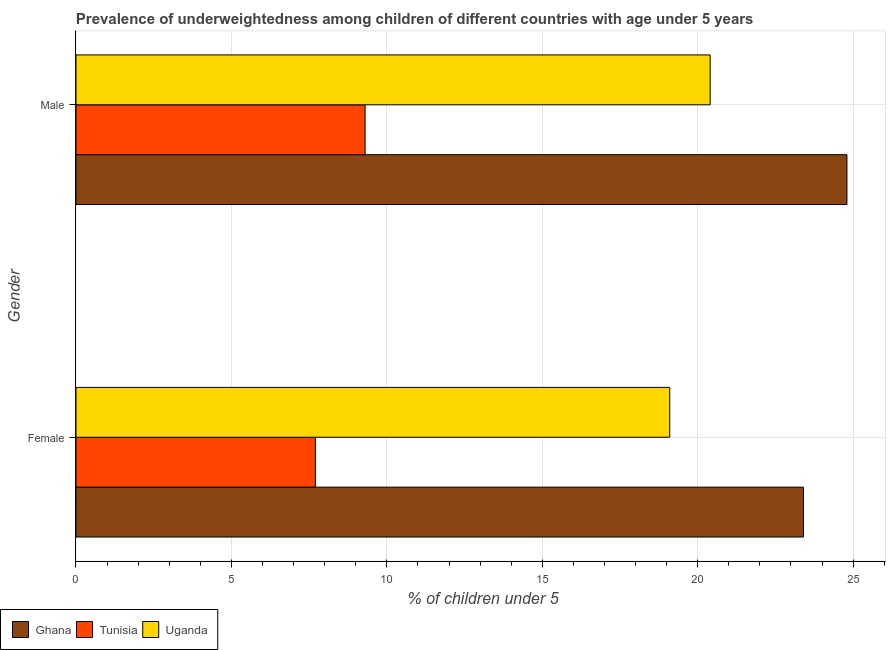How many different coloured bars are there?
Provide a succinct answer. 3. How many groups of bars are there?
Your answer should be very brief. 2. Are the number of bars on each tick of the Y-axis equal?
Provide a succinct answer. Yes. How many bars are there on the 2nd tick from the bottom?
Offer a very short reply. 3. What is the label of the 1st group of bars from the top?
Offer a very short reply. Male. What is the percentage of underweighted female children in Tunisia?
Make the answer very short. 7.7. Across all countries, what is the maximum percentage of underweighted male children?
Offer a very short reply. 24.8. Across all countries, what is the minimum percentage of underweighted male children?
Your response must be concise. 9.3. In which country was the percentage of underweighted female children minimum?
Provide a succinct answer. Tunisia. What is the total percentage of underweighted female children in the graph?
Your answer should be very brief. 50.2. What is the difference between the percentage of underweighted female children in Uganda and that in Tunisia?
Your answer should be compact. 11.4. What is the difference between the percentage of underweighted male children in Tunisia and the percentage of underweighted female children in Uganda?
Make the answer very short. -9.8. What is the average percentage of underweighted female children per country?
Your response must be concise. 16.73. What is the difference between the percentage of underweighted female children and percentage of underweighted male children in Ghana?
Your answer should be compact. -1.4. What is the ratio of the percentage of underweighted male children in Ghana to that in Tunisia?
Offer a very short reply. 2.67. Is the percentage of underweighted male children in Tunisia less than that in Ghana?
Your answer should be compact. Yes. What does the 1st bar from the top in Female represents?
Your answer should be compact. Uganda. What does the 1st bar from the bottom in Male represents?
Provide a short and direct response. Ghana. How many bars are there?
Provide a succinct answer. 6. Are the values on the major ticks of X-axis written in scientific E-notation?
Give a very brief answer. No. Does the graph contain grids?
Offer a terse response. Yes. How are the legend labels stacked?
Make the answer very short. Horizontal. What is the title of the graph?
Provide a succinct answer. Prevalence of underweightedness among children of different countries with age under 5 years. Does "Lower middle income" appear as one of the legend labels in the graph?
Offer a very short reply. No. What is the label or title of the X-axis?
Ensure brevity in your answer.   % of children under 5. What is the  % of children under 5 in Ghana in Female?
Ensure brevity in your answer.  23.4. What is the  % of children under 5 of Tunisia in Female?
Make the answer very short. 7.7. What is the  % of children under 5 of Uganda in Female?
Offer a terse response. 19.1. What is the  % of children under 5 in Ghana in Male?
Make the answer very short. 24.8. What is the  % of children under 5 of Tunisia in Male?
Make the answer very short. 9.3. What is the  % of children under 5 in Uganda in Male?
Give a very brief answer. 20.4. Across all Gender, what is the maximum  % of children under 5 of Ghana?
Offer a very short reply. 24.8. Across all Gender, what is the maximum  % of children under 5 in Tunisia?
Give a very brief answer. 9.3. Across all Gender, what is the maximum  % of children under 5 in Uganda?
Your answer should be very brief. 20.4. Across all Gender, what is the minimum  % of children under 5 of Ghana?
Your response must be concise. 23.4. Across all Gender, what is the minimum  % of children under 5 in Tunisia?
Your answer should be very brief. 7.7. Across all Gender, what is the minimum  % of children under 5 of Uganda?
Offer a very short reply. 19.1. What is the total  % of children under 5 in Ghana in the graph?
Offer a very short reply. 48.2. What is the total  % of children under 5 in Tunisia in the graph?
Provide a short and direct response. 17. What is the total  % of children under 5 of Uganda in the graph?
Your response must be concise. 39.5. What is the difference between the  % of children under 5 of Uganda in Female and that in Male?
Your answer should be compact. -1.3. What is the difference between the  % of children under 5 of Ghana in Female and the  % of children under 5 of Uganda in Male?
Your answer should be very brief. 3. What is the difference between the  % of children under 5 in Tunisia in Female and the  % of children under 5 in Uganda in Male?
Give a very brief answer. -12.7. What is the average  % of children under 5 of Ghana per Gender?
Keep it short and to the point. 24.1. What is the average  % of children under 5 of Uganda per Gender?
Make the answer very short. 19.75. What is the difference between the  % of children under 5 in Ghana and  % of children under 5 in Tunisia in Female?
Make the answer very short. 15.7. What is the difference between the  % of children under 5 of Ghana and  % of children under 5 of Uganda in Female?
Keep it short and to the point. 4.3. What is the difference between the  % of children under 5 of Tunisia and  % of children under 5 of Uganda in Female?
Give a very brief answer. -11.4. What is the difference between the  % of children under 5 of Ghana and  % of children under 5 of Tunisia in Male?
Offer a terse response. 15.5. What is the difference between the  % of children under 5 in Ghana and  % of children under 5 in Uganda in Male?
Offer a terse response. 4.4. What is the ratio of the  % of children under 5 of Ghana in Female to that in Male?
Your response must be concise. 0.94. What is the ratio of the  % of children under 5 of Tunisia in Female to that in Male?
Offer a terse response. 0.83. What is the ratio of the  % of children under 5 of Uganda in Female to that in Male?
Your answer should be compact. 0.94. What is the difference between the highest and the second highest  % of children under 5 of Ghana?
Keep it short and to the point. 1.4. What is the difference between the highest and the lowest  % of children under 5 in Tunisia?
Ensure brevity in your answer.  1.6. What is the difference between the highest and the lowest  % of children under 5 in Uganda?
Provide a succinct answer. 1.3. 